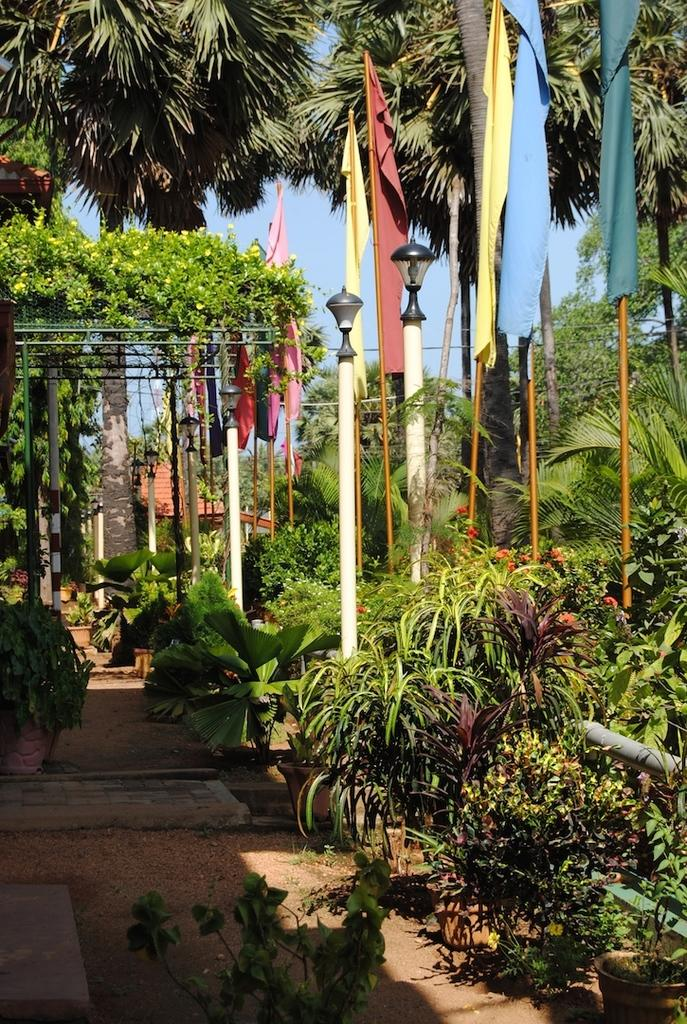What type of natural elements can be seen in the image? There are plants and trees in the image. What man-made objects are present in the image? There are flags and light poles in the image. What can be seen in the background of the image? The sky is visible in the background of the image. What type of smell can be detected from the plants in the image? There is no information about the smell of the plants in the image, so it cannot be determined. 